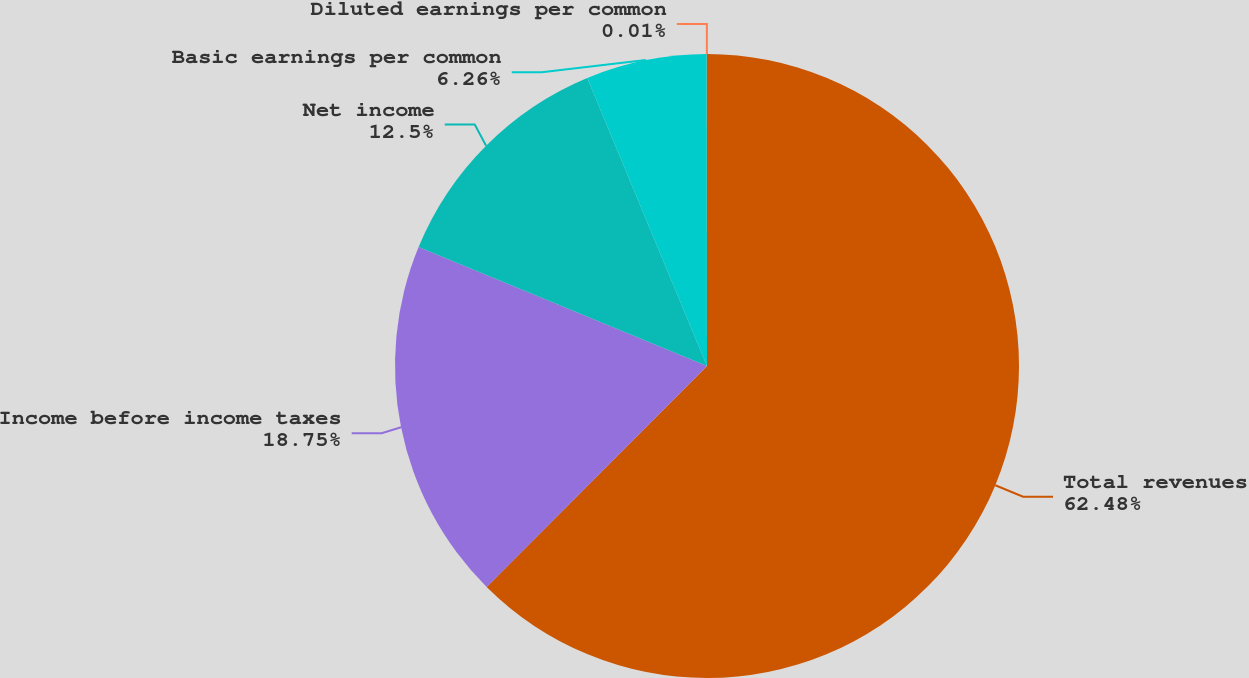<chart> <loc_0><loc_0><loc_500><loc_500><pie_chart><fcel>Total revenues<fcel>Income before income taxes<fcel>Net income<fcel>Basic earnings per common<fcel>Diluted earnings per common<nl><fcel>62.48%<fcel>18.75%<fcel>12.5%<fcel>6.26%<fcel>0.01%<nl></chart> 